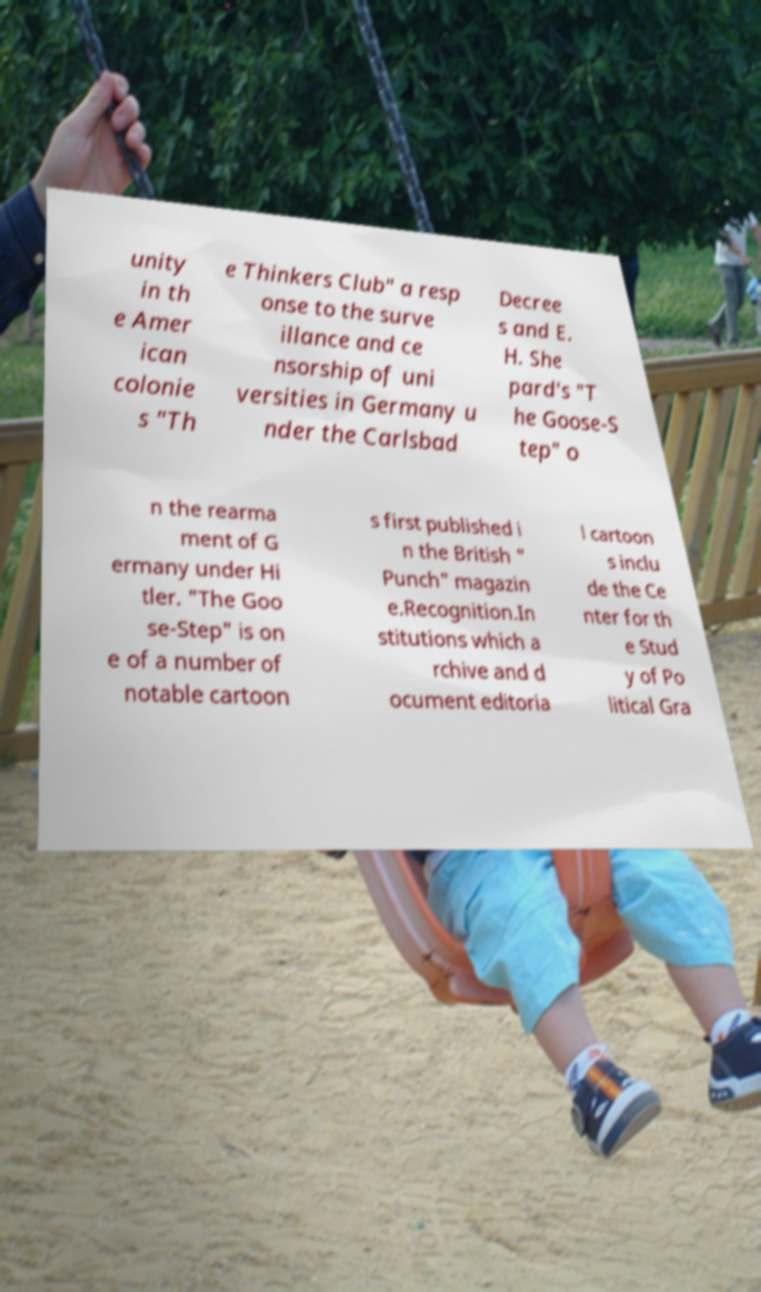For documentation purposes, I need the text within this image transcribed. Could you provide that? unity in th e Amer ican colonie s "Th e Thinkers Club" a resp onse to the surve illance and ce nsorship of uni versities in Germany u nder the Carlsbad Decree s and E. H. She pard's "T he Goose-S tep" o n the rearma ment of G ermany under Hi tler. "The Goo se-Step" is on e of a number of notable cartoon s first published i n the British " Punch" magazin e.Recognition.In stitutions which a rchive and d ocument editoria l cartoon s inclu de the Ce nter for th e Stud y of Po litical Gra 